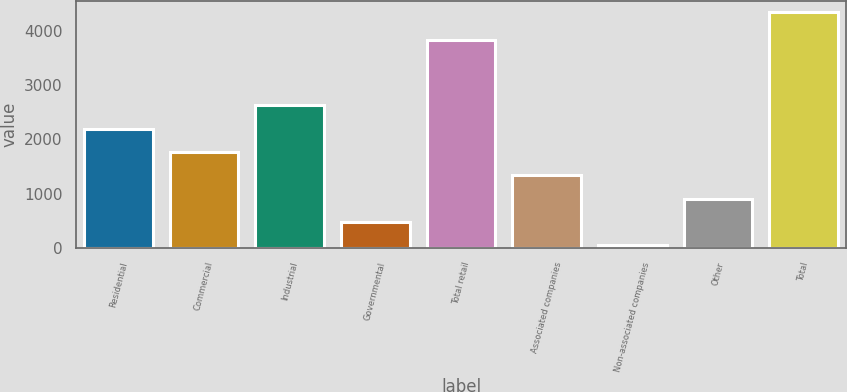<chart> <loc_0><loc_0><loc_500><loc_500><bar_chart><fcel>Residential<fcel>Commercial<fcel>Industrial<fcel>Governmental<fcel>Total retail<fcel>Associated companies<fcel>Non-associated companies<fcel>Other<fcel>Total<nl><fcel>2194<fcel>1764.8<fcel>2623.2<fcel>477.2<fcel>3832<fcel>1335.6<fcel>48<fcel>906.4<fcel>4340<nl></chart> 